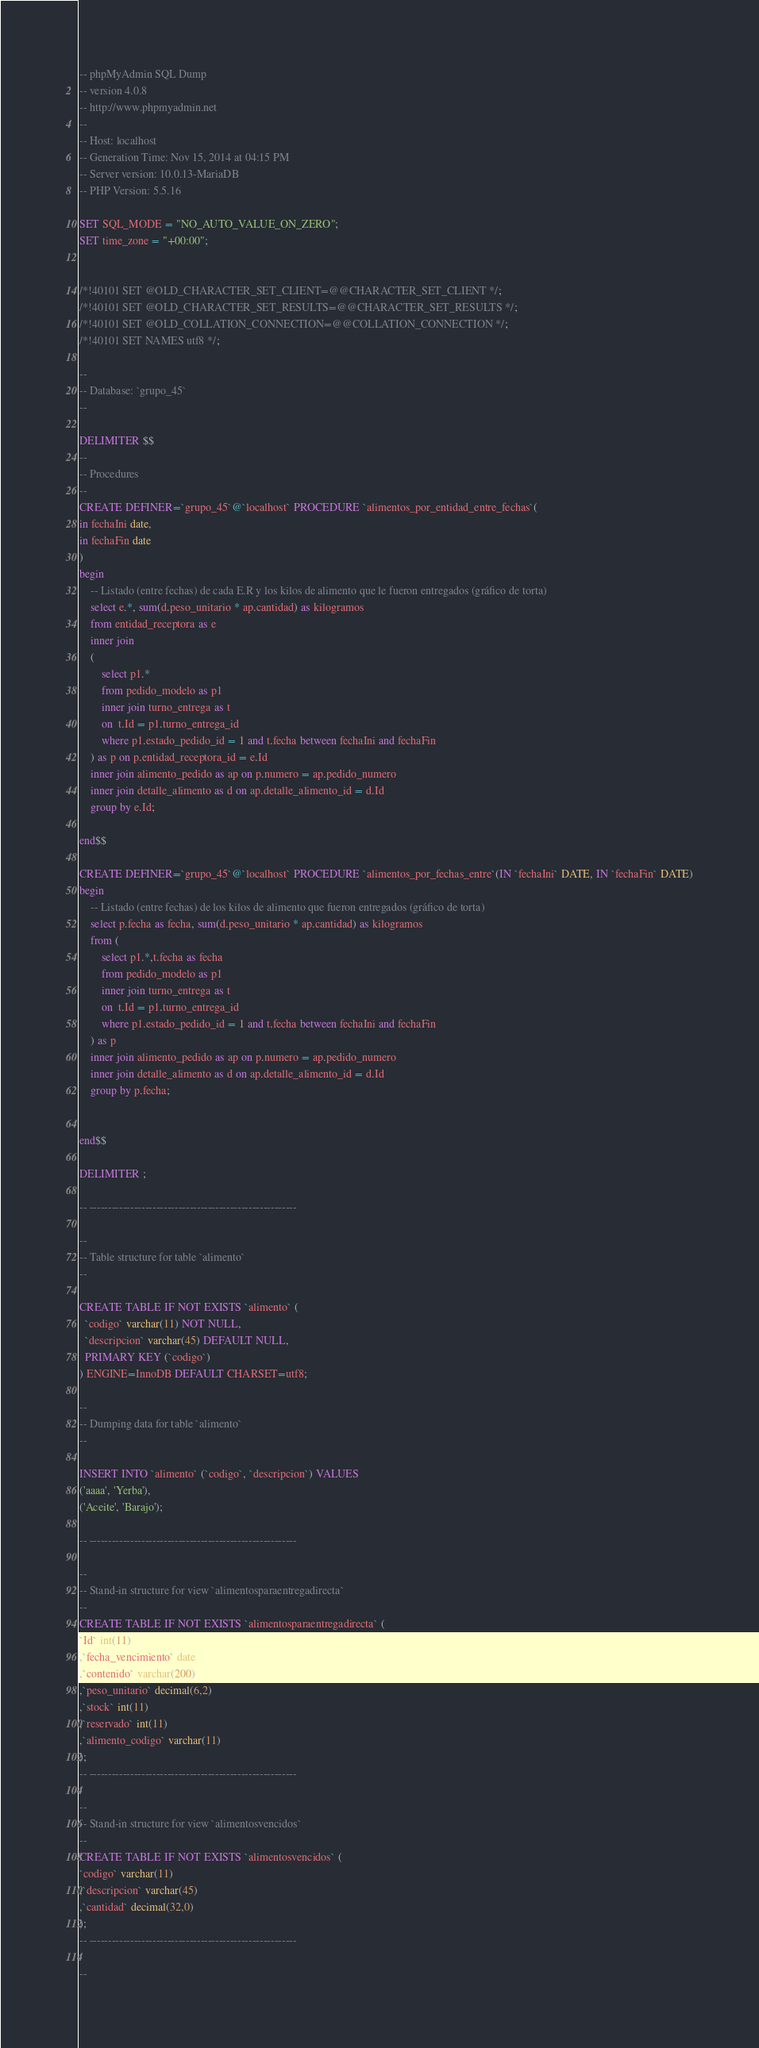Convert code to text. <code><loc_0><loc_0><loc_500><loc_500><_SQL_>-- phpMyAdmin SQL Dump
-- version 4.0.8
-- http://www.phpmyadmin.net
--
-- Host: localhost
-- Generation Time: Nov 15, 2014 at 04:15 PM
-- Server version: 10.0.13-MariaDB
-- PHP Version: 5.5.16

SET SQL_MODE = "NO_AUTO_VALUE_ON_ZERO";
SET time_zone = "+00:00";


/*!40101 SET @OLD_CHARACTER_SET_CLIENT=@@CHARACTER_SET_CLIENT */;
/*!40101 SET @OLD_CHARACTER_SET_RESULTS=@@CHARACTER_SET_RESULTS */;
/*!40101 SET @OLD_COLLATION_CONNECTION=@@COLLATION_CONNECTION */;
/*!40101 SET NAMES utf8 */;

--
-- Database: `grupo_45`
--

DELIMITER $$
--
-- Procedures
--
CREATE DEFINER=`grupo_45`@`localhost` PROCEDURE `alimentos_por_entidad_entre_fechas`(
in fechaIni date,
in fechaFin date
)
begin
	-- Listado (entre fechas) de cada E.R y los kilos de alimento que le fueron entregados (gráfico de torta)
	select e.*, sum(d.peso_unitario * ap.cantidad) as kilogramos
	from entidad_receptora as e
	inner join 
	(
		select p1.* 
		from pedido_modelo as p1 
		inner join turno_entrega as t 
		on  t.Id = p1.turno_entrega_id
		where p1.estado_pedido_id = 1 and t.fecha between fechaIni and fechaFin
	) as p on p.entidad_receptora_id = e.Id
	inner join alimento_pedido as ap on p.numero = ap.pedido_numero
	inner join detalle_alimento as d on ap.detalle_alimento_id = d.Id
	group by e.Id;

end$$

CREATE DEFINER=`grupo_45`@`localhost` PROCEDURE `alimentos_por_fechas_entre`(IN `fechaIni` DATE, IN `fechaFin` DATE)
begin
	-- Listado (entre fechas) de los kilos de alimento que fueron entregados (gráfico de torta)
	select p.fecha as fecha, sum(d.peso_unitario * ap.cantidad) as kilogramos
	from (
		select p1.*,t.fecha as fecha
		from pedido_modelo as p1 
		inner join turno_entrega as t 
		on  t.Id = p1.turno_entrega_id
		where p1.estado_pedido_id = 1 and t.fecha between fechaIni and fechaFin
	) as p 
	inner join alimento_pedido as ap on p.numero = ap.pedido_numero
	inner join detalle_alimento as d on ap.detalle_alimento_id = d.Id
	group by p.fecha;
	

end$$

DELIMITER ;

-- --------------------------------------------------------

--
-- Table structure for table `alimento`
--

CREATE TABLE IF NOT EXISTS `alimento` (
  `codigo` varchar(11) NOT NULL,
  `descripcion` varchar(45) DEFAULT NULL,
  PRIMARY KEY (`codigo`)
) ENGINE=InnoDB DEFAULT CHARSET=utf8;

--
-- Dumping data for table `alimento`
--

INSERT INTO `alimento` (`codigo`, `descripcion`) VALUES
('aaaa', 'Yerba'),
('Aceite', 'Barajo');

-- --------------------------------------------------------

--
-- Stand-in structure for view `alimentosparaentregadirecta`
--
CREATE TABLE IF NOT EXISTS `alimentosparaentregadirecta` (
`Id` int(11)
,`fecha_vencimiento` date
,`contenido` varchar(200)
,`peso_unitario` decimal(6,2)
,`stock` int(11)
,`reservado` int(11)
,`alimento_codigo` varchar(11)
);
-- --------------------------------------------------------

--
-- Stand-in structure for view `alimentosvencidos`
--
CREATE TABLE IF NOT EXISTS `alimentosvencidos` (
`codigo` varchar(11)
,`descripcion` varchar(45)
,`cantidad` decimal(32,0)
);
-- --------------------------------------------------------

--</code> 